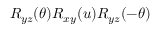<formula> <loc_0><loc_0><loc_500><loc_500>R _ { y z } ( \theta ) R _ { x y } ( u ) R _ { y z } ( - \theta )</formula> 